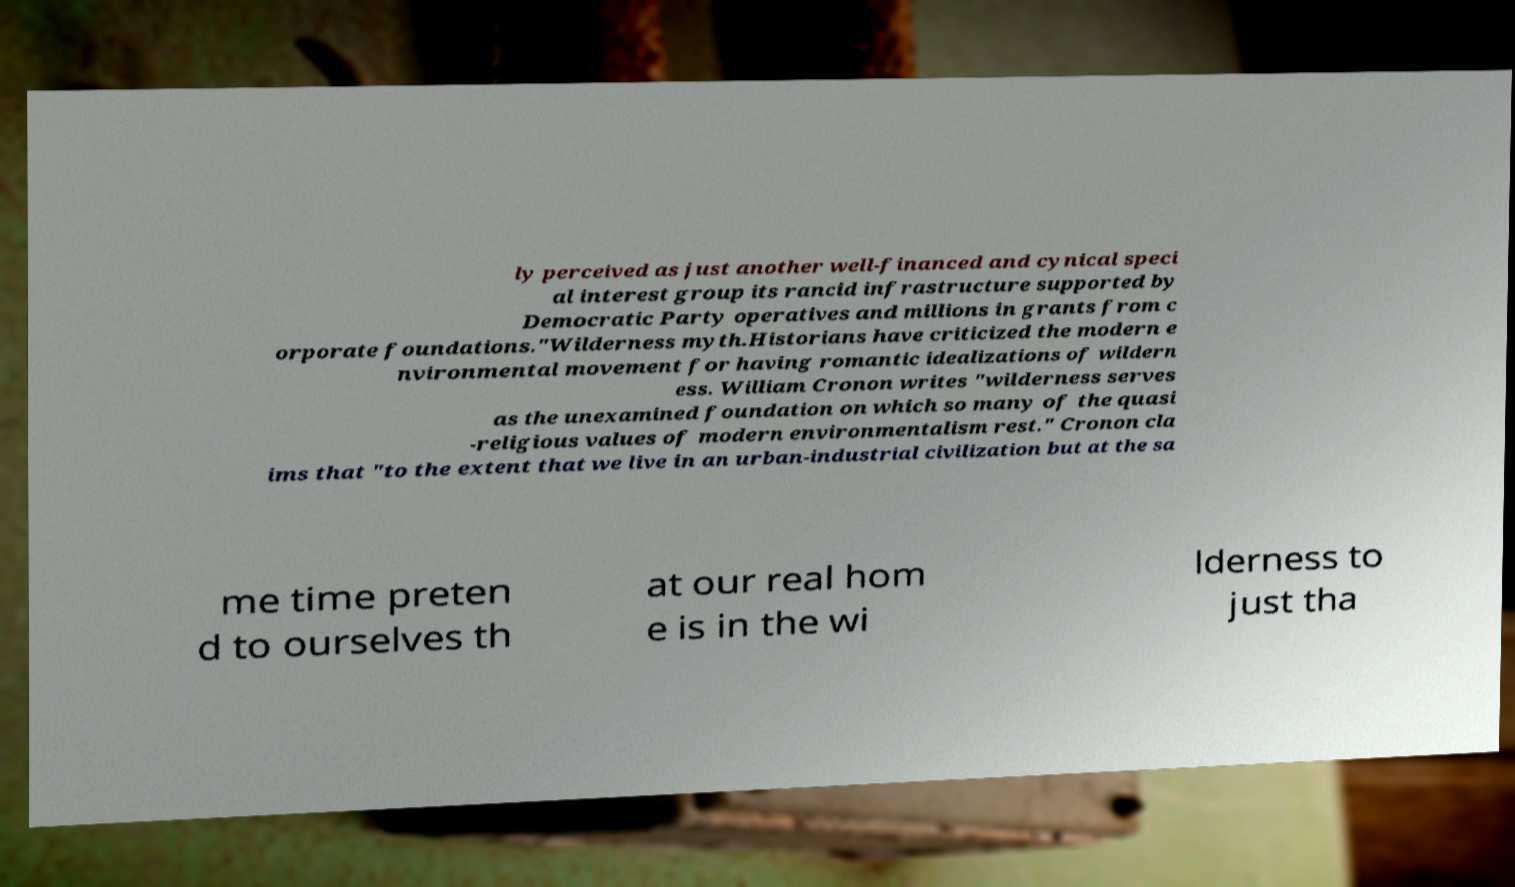Please identify and transcribe the text found in this image. ly perceived as just another well-financed and cynical speci al interest group its rancid infrastructure supported by Democratic Party operatives and millions in grants from c orporate foundations."Wilderness myth.Historians have criticized the modern e nvironmental movement for having romantic idealizations of wildern ess. William Cronon writes "wilderness serves as the unexamined foundation on which so many of the quasi -religious values of modern environmentalism rest." Cronon cla ims that "to the extent that we live in an urban-industrial civilization but at the sa me time preten d to ourselves th at our real hom e is in the wi lderness to just tha 